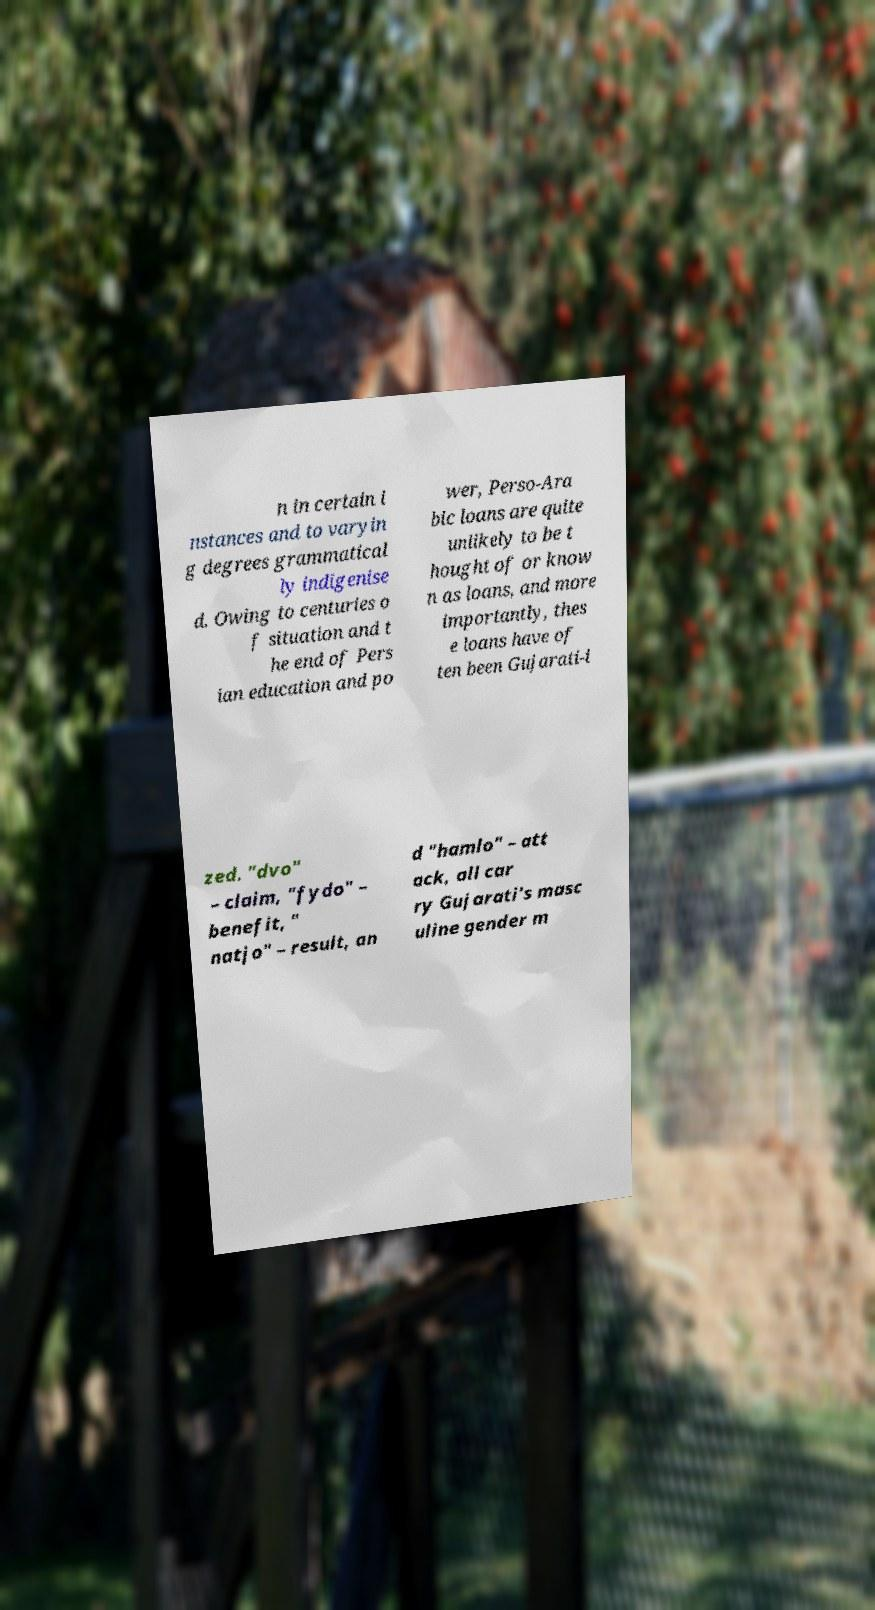What messages or text are displayed in this image? I need them in a readable, typed format. n in certain i nstances and to varyin g degrees grammatical ly indigenise d. Owing to centuries o f situation and t he end of Pers ian education and po wer, Perso-Ara bic loans are quite unlikely to be t hought of or know n as loans, and more importantly, thes e loans have of ten been Gujarati-i zed. "dvo" – claim, "fydo" – benefit, " natjo" – result, an d "hamlo" – att ack, all car ry Gujarati's masc uline gender m 